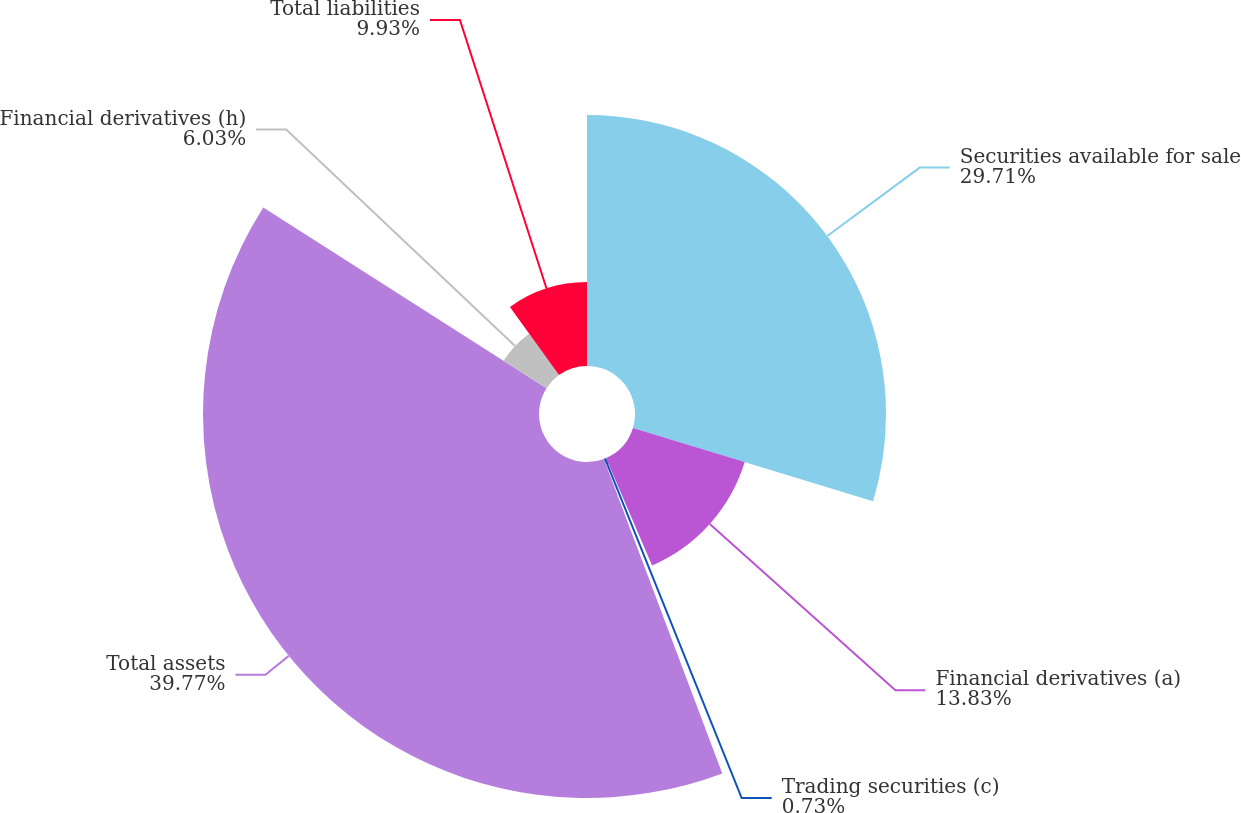Convert chart. <chart><loc_0><loc_0><loc_500><loc_500><pie_chart><fcel>Securities available for sale<fcel>Financial derivatives (a)<fcel>Trading securities (c)<fcel>Total assets<fcel>Financial derivatives (h)<fcel>Total liabilities<nl><fcel>29.71%<fcel>13.83%<fcel>0.73%<fcel>39.77%<fcel>6.03%<fcel>9.93%<nl></chart> 